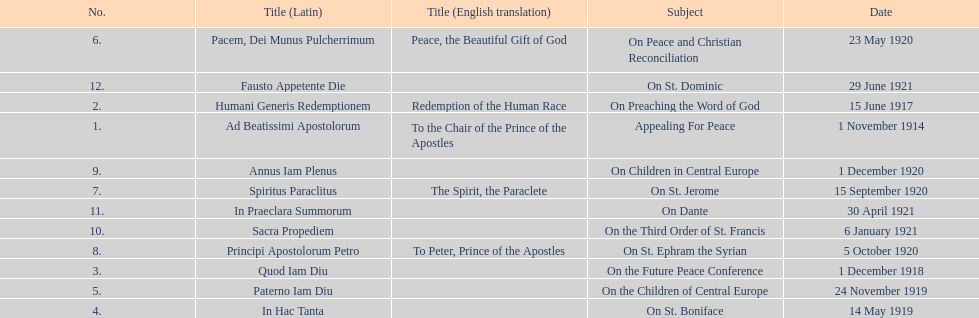After 1 december 1918 when was the next encyclical? 14 May 1919. 